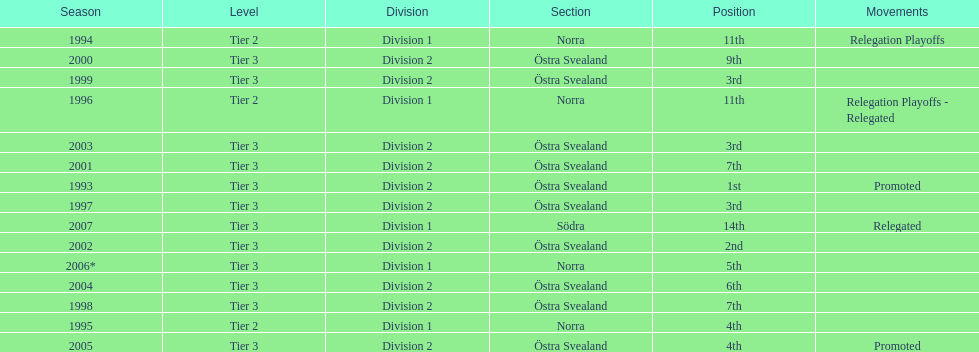In what season did visby if gute fk finish first in division 2 tier 3? 1993. 